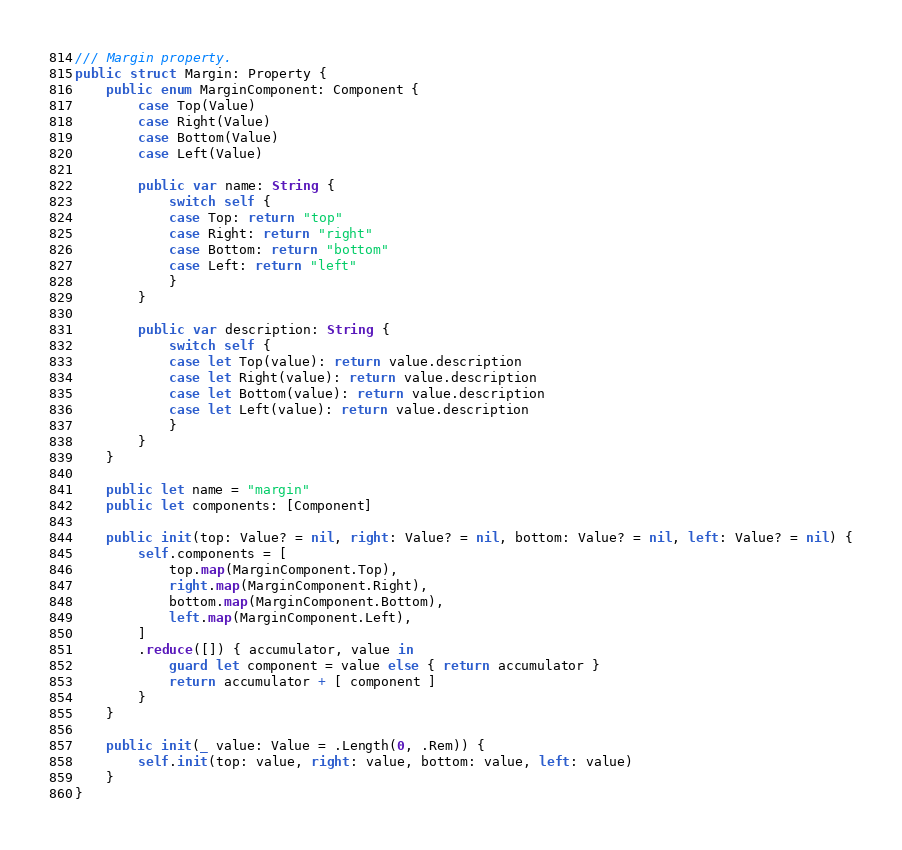<code> <loc_0><loc_0><loc_500><loc_500><_Swift_>/// Margin property.
public struct Margin: Property {
    public enum MarginComponent: Component {
        case Top(Value)
        case Right(Value)
        case Bottom(Value)
        case Left(Value)

        public var name: String {
            switch self {
            case Top: return "top"
            case Right: return "right"
            case Bottom: return "bottom"
            case Left: return "left"
            }
        }

        public var description: String {
            switch self {
            case let Top(value): return value.description
            case let Right(value): return value.description
            case let Bottom(value): return value.description
            case let Left(value): return value.description
            }
        }
    }
    
    public let name = "margin"
    public let components: [Component]
    
    public init(top: Value? = nil, right: Value? = nil, bottom: Value? = nil, left: Value? = nil) {
        self.components = [
            top.map(MarginComponent.Top),
            right.map(MarginComponent.Right),
            bottom.map(MarginComponent.Bottom),
            left.map(MarginComponent.Left),
        ]
        .reduce([]) { accumulator, value in
            guard let component = value else { return accumulator }
            return accumulator + [ component ]
        }
    }
    
    public init(_ value: Value = .Length(0, .Rem)) {
        self.init(top: value, right: value, bottom: value, left: value)
    }
}
</code> 